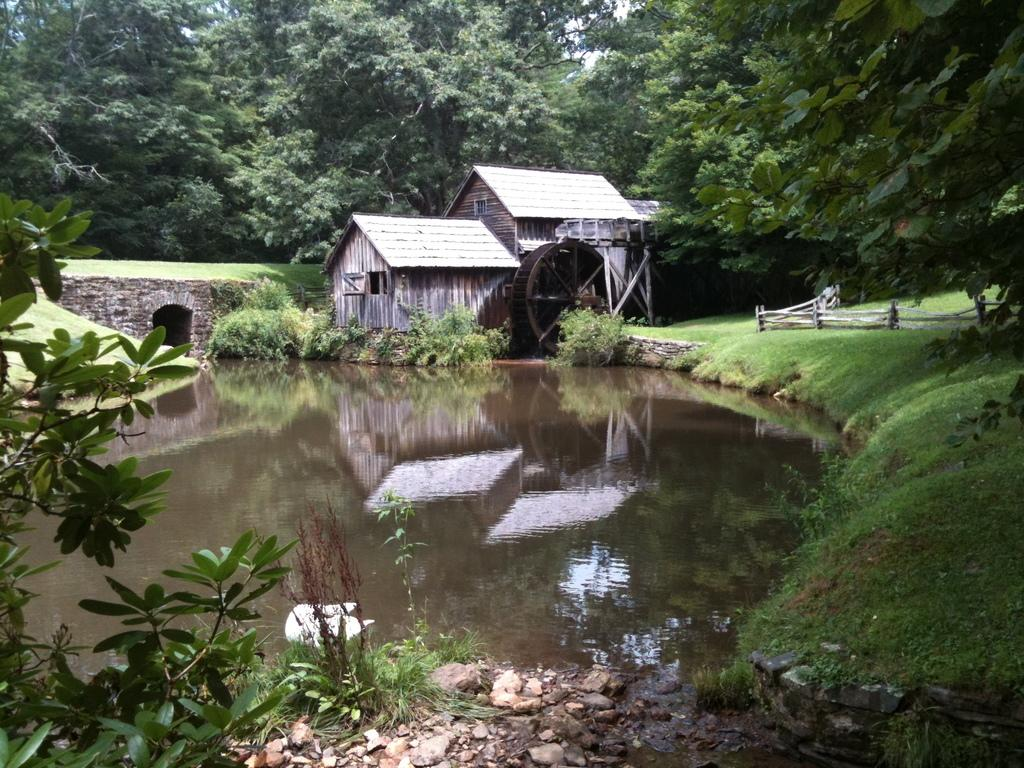What can be seen in the foreground of the picture? In the foreground of the picture, there are stones, grass, plants, and water. What is located in the center of the picture? In the center of the picture, there is a house, glass, and railing. What type of vegetation is visible in the picture? There are plants in the foreground and trees in the background of the picture. Are there any fairies visible in the picture? There are no fairies present in the image. What type of operation is being performed on the house in the picture? There is no operation being performed on the house in the picture; it is simply a part of the image's landscape. 